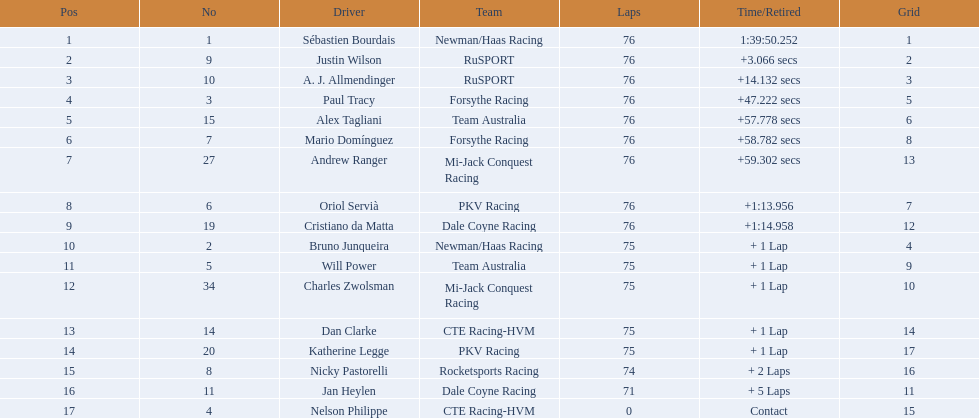Who drove during the 2006 tecate grand prix of monterrey? Sébastien Bourdais, Justin Wilson, A. J. Allmendinger, Paul Tracy, Alex Tagliani, Mario Domínguez, Andrew Ranger, Oriol Servià, Cristiano da Matta, Bruno Junqueira, Will Power, Charles Zwolsman, Dan Clarke, Katherine Legge, Nicky Pastorelli, Jan Heylen, Nelson Philippe. And what were their finishing positions? 1, 2, 3, 4, 5, 6, 7, 8, 9, 10, 11, 12, 13, 14, 15, 16, 17. Who did alex tagliani finish directly behind of? Paul Tracy. 